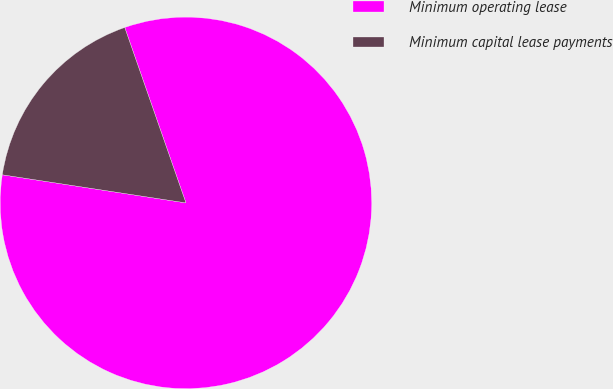Convert chart. <chart><loc_0><loc_0><loc_500><loc_500><pie_chart><fcel>Minimum operating lease<fcel>Minimum capital lease payments<nl><fcel>82.76%<fcel>17.24%<nl></chart> 